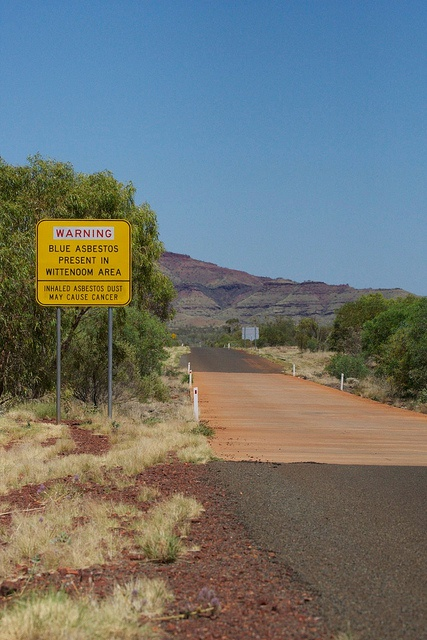Describe the objects in this image and their specific colors. I can see various objects in this image with different colors. 